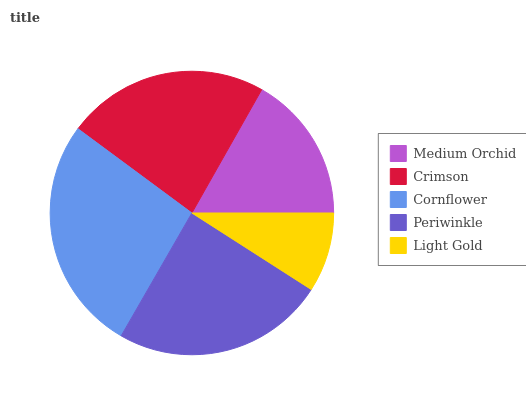Is Light Gold the minimum?
Answer yes or no. Yes. Is Cornflower the maximum?
Answer yes or no. Yes. Is Crimson the minimum?
Answer yes or no. No. Is Crimson the maximum?
Answer yes or no. No. Is Crimson greater than Medium Orchid?
Answer yes or no. Yes. Is Medium Orchid less than Crimson?
Answer yes or no. Yes. Is Medium Orchid greater than Crimson?
Answer yes or no. No. Is Crimson less than Medium Orchid?
Answer yes or no. No. Is Crimson the high median?
Answer yes or no. Yes. Is Crimson the low median?
Answer yes or no. Yes. Is Periwinkle the high median?
Answer yes or no. No. Is Periwinkle the low median?
Answer yes or no. No. 